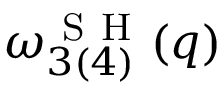<formula> <loc_0><loc_0><loc_500><loc_500>\omega _ { 3 ( 4 ) } ^ { S H } ( q )</formula> 